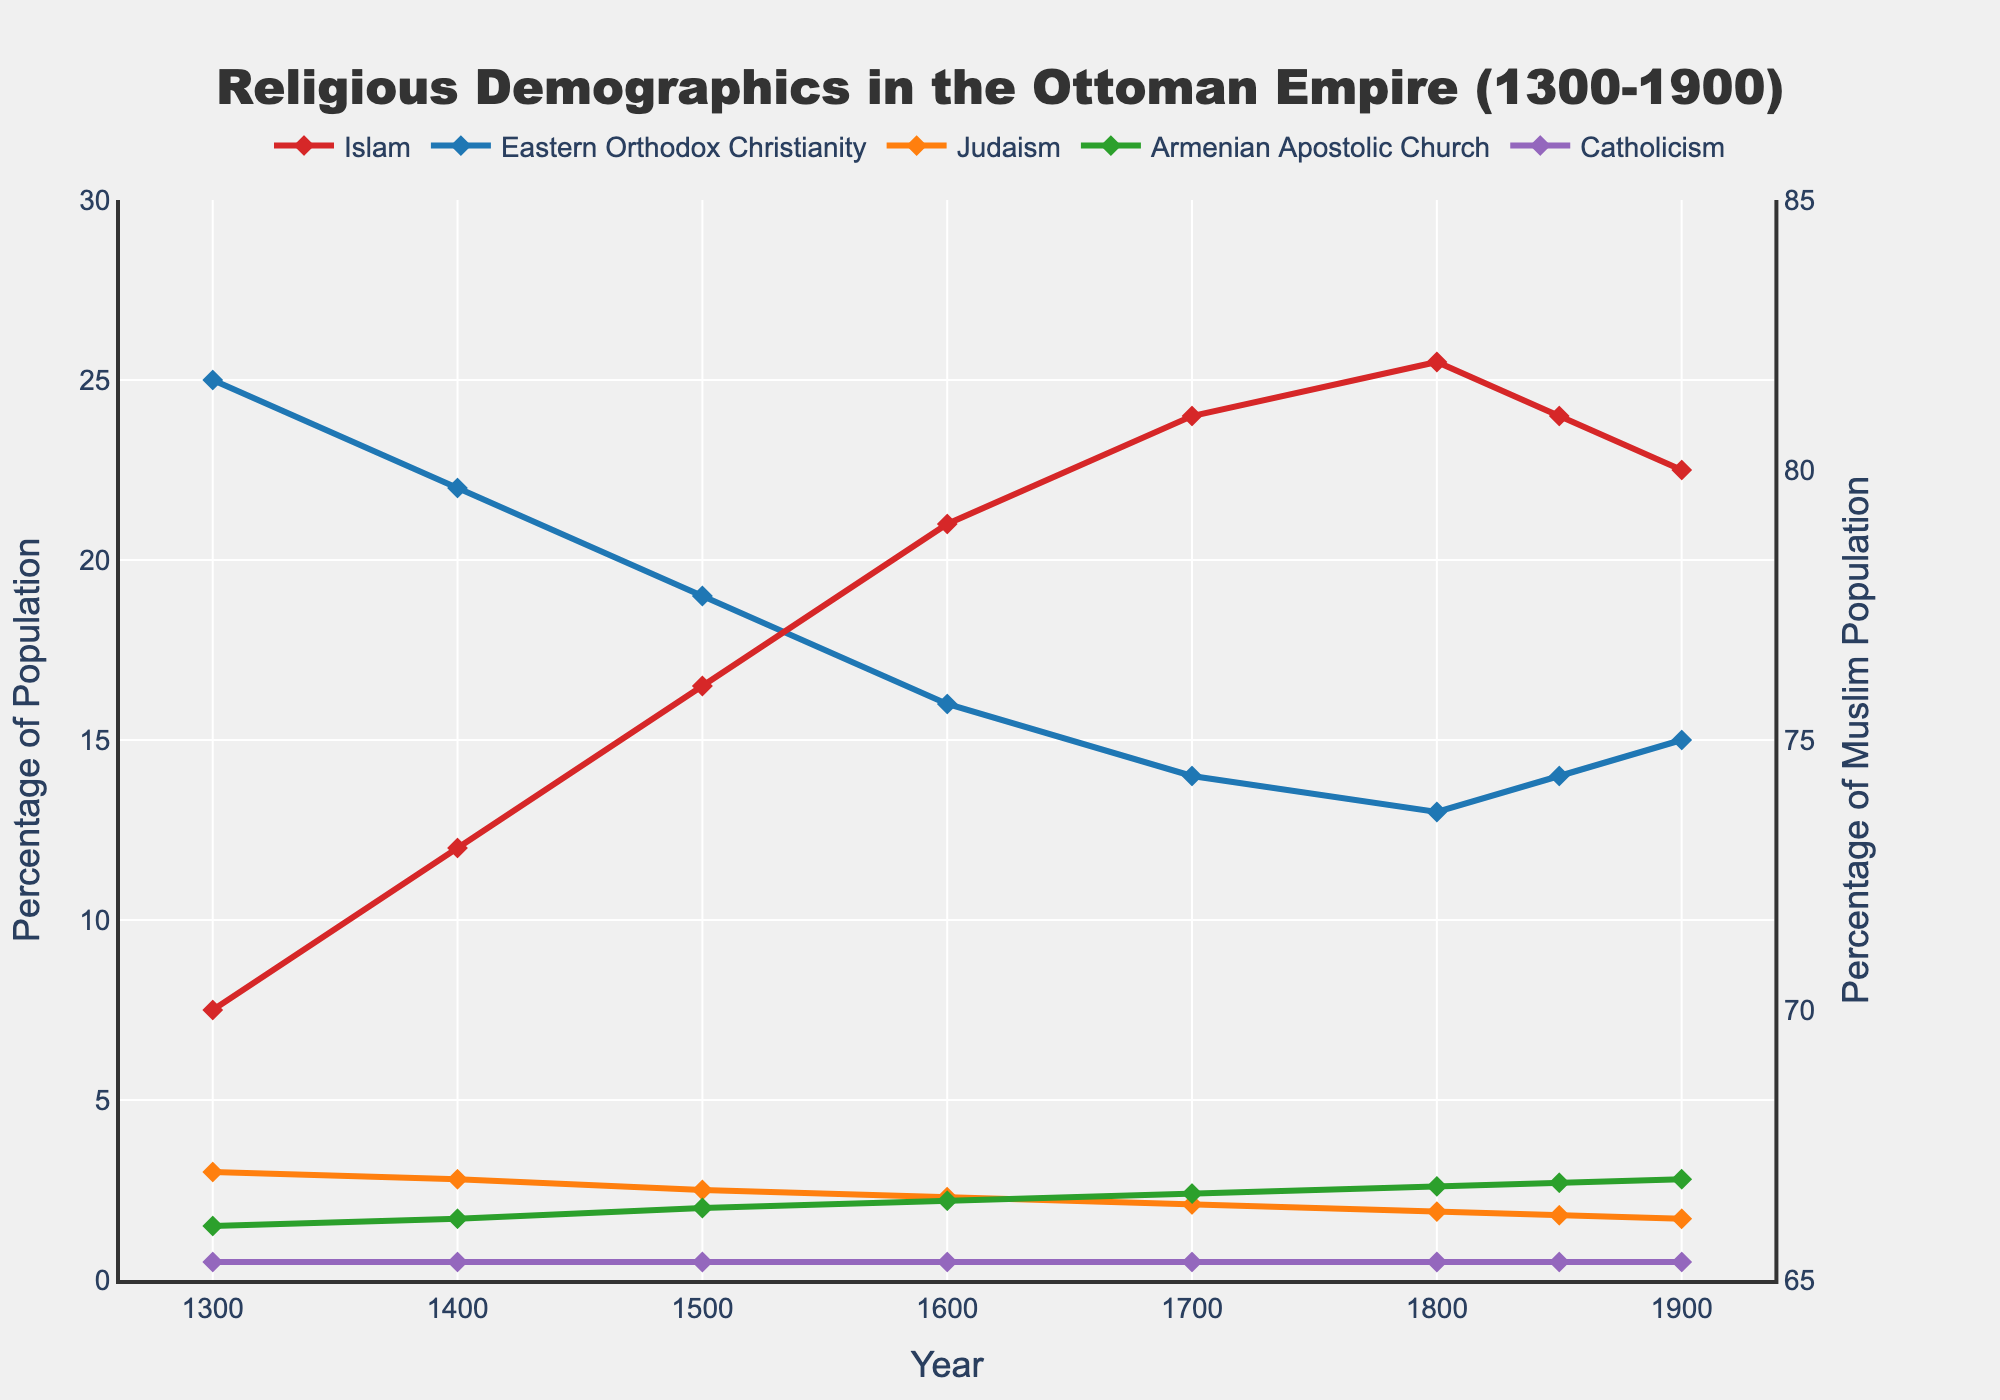What was the percentage change in the Muslim population from 1300 to 1800? To find the percentage change, we use the formula: ((new value - old value) / old value) * 100. The percentage of Muslims in 1300 was 70%, and in 1800 it was 82%. So, the calculation is ((82 - 70) / 70) * 100 = (12 / 70) * 100 = 17.14%.
Answer: 17.14% Which religious group had the smallest percentage change from 1300 to 1900? Looking at the data, we need to calculate the percentage change for each group. Islam: ((80-70)/70)*100 = 14.29%, Eastern Orthodox Christianity: ((15-25)/25)*100 = -40%, Judaism: ((1.7-3)/3)*100 = -43.33%, Armenian Apostolic Church: ((2.8-1.5)/1.5)*100 = 86.67%, Catholicism: no change, always 0.5%. The smallest percentage change is for Catholicism at 0%.
Answer: Catholicism Between which two years did Eastern Orthodox Christianity see the largest decline in percentage? By examining the data, the percentage of Eastern Orthodox Christianity in 1300 was 25%, and it continually decreases. The largest decline occurred between 1300 and 1400, going from 25% to 22%, a decrease of 3%.
Answer: Between 1300 and 1400 Compared to Eastern Orthodox Christianity, how did the percentage of the Armenian Apostolic Church change between 1400 and 1800? In 1400, Eastern Orthodox Christianity was at 22% and declined to 13% in 1800, a decrease of 9%. The Armenian Apostolic Church was at 1.7% in 1400 and increased to 2.6% in 1800, an increase of 0.9%. Thus, Eastern Orthodox Christianity decreased by 9%, while the Armenian Apostolic Church increased by 0.9% during the same period.
Answer: Eastern Orthodox Christianity decreased by 9%, Armenian Apostolic Church increased by 0.9% What is the difference between the maximum and minimum percentages of the Jewish population? The maximum percentage of the Jewish population was 3% in 1300, and the minimum was 1.7% in 1900. The difference is 3% - 1.7% = 1.3%.
Answer: 1.3% In which year did the percentage of Muslims peak, and what was the value? By examining the chart, the percentage of Muslims peaked in 1800 with a value of 82%.
Answer: 1800, 82% How did the overall population of non-Muslim faiths trend from 1300 to 1900? Adding up the percentages of all non-Muslim faiths for 1300 and 1900, in 1300, it was 25 + 3 + 1.5 + 0.5 = 30%, and in 1900 it was 15 + 1.7 + 2.8 + 0.5 = 20%. There is a general decrease in the overall population of non-Muslim faiths from 30% to 20%.
Answer: Decreased from 30% to 20% Which group saw the most significant percent increase from 1300 to 1900? Calculating the percent increase for each group: Islam: ((80-70)/70)*100 = 14.29%, Eastern Orthodox Christianity: ((15-25)/25)*100 = -40%, Judaism: ((1.7-3)/3)*100 = -43.33%, Armenian Apostolic Church: ((2.8-1.5)/1.5)*100 = 86.67%, Catholicism: no change, always 0.5%. The most significant percent increase was for the Armenian Apostolic Church at 86.67%.
Answer: Armenian Apostolic Church Which religious group maintained the most consistent population percentage throughout the timeline? By examining the figures visually, Catholicism maintained a consistent population percentage of 0.5% from 1300 to 1900.
Answer: Catholicism 